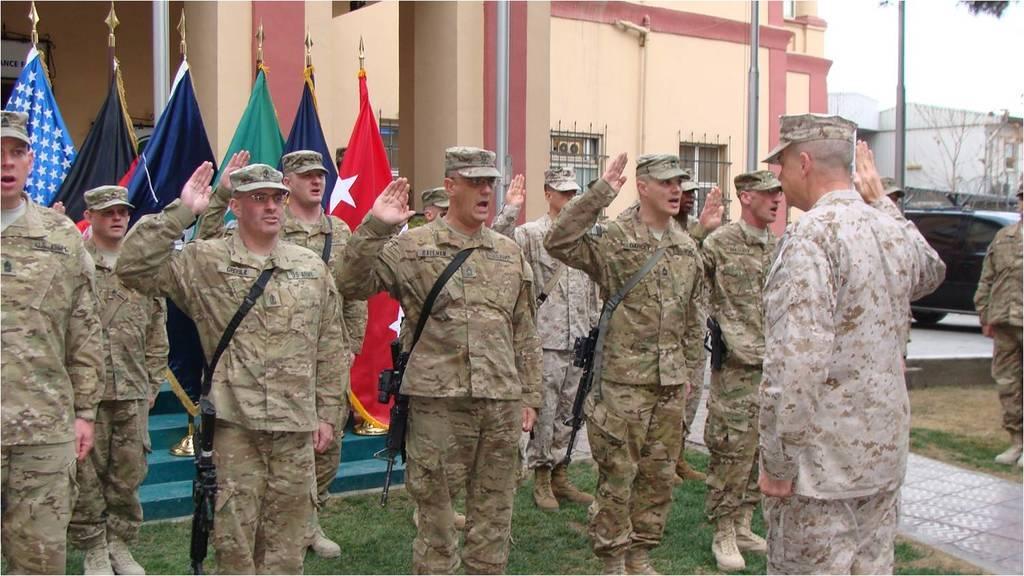Please provide a concise description of this image. In this picture we can see a group of men standing on the grass, vehicle on the ground, flags, buildings, poles, trees, some objects and in the background we can see the sky. 